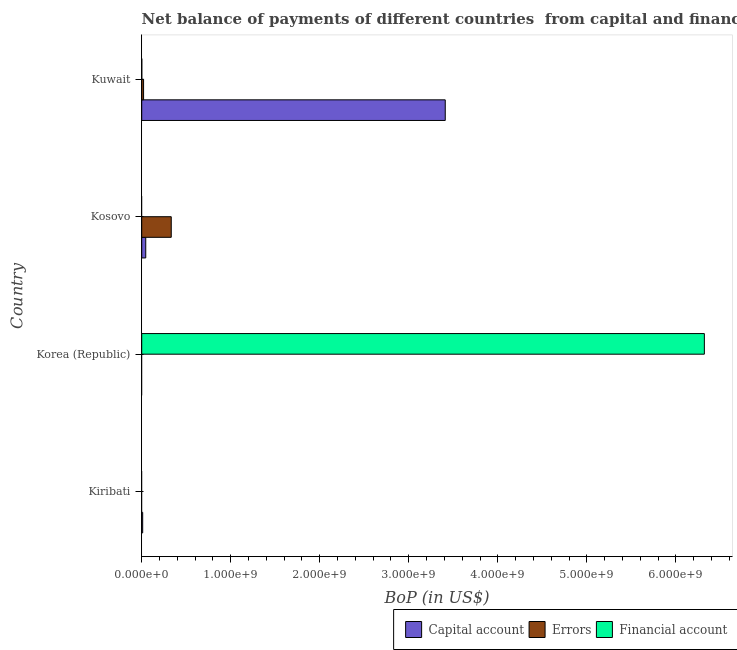Are the number of bars per tick equal to the number of legend labels?
Offer a terse response. No. How many bars are there on the 4th tick from the top?
Keep it short and to the point. 1. What is the label of the 2nd group of bars from the top?
Make the answer very short. Kosovo. What is the amount of financial account in Kiribati?
Offer a very short reply. 0. Across all countries, what is the maximum amount of financial account?
Keep it short and to the point. 6.32e+09. In which country was the amount of errors maximum?
Provide a short and direct response. Kosovo. What is the total amount of errors in the graph?
Provide a short and direct response. 3.53e+08. What is the difference between the amount of financial account in Korea (Republic) and that in Kuwait?
Your answer should be compact. 6.32e+09. What is the difference between the amount of net capital account in Kosovo and the amount of financial account in Korea (Republic)?
Offer a very short reply. -6.28e+09. What is the average amount of errors per country?
Make the answer very short. 8.82e+07. What is the difference between the amount of financial account and amount of net capital account in Kuwait?
Your answer should be compact. -3.41e+09. What is the ratio of the amount of net capital account in Kosovo to that in Kuwait?
Provide a short and direct response. 0.01. What is the difference between the highest and the second highest amount of net capital account?
Your answer should be very brief. 3.36e+09. What is the difference between the highest and the lowest amount of net capital account?
Your answer should be compact. 3.41e+09. In how many countries, is the amount of financial account greater than the average amount of financial account taken over all countries?
Offer a terse response. 1. Is it the case that in every country, the sum of the amount of net capital account and amount of errors is greater than the amount of financial account?
Your response must be concise. No. How many bars are there?
Your answer should be very brief. 7. Are the values on the major ticks of X-axis written in scientific E-notation?
Ensure brevity in your answer.  Yes. Does the graph contain grids?
Make the answer very short. No. Where does the legend appear in the graph?
Provide a short and direct response. Bottom right. What is the title of the graph?
Your answer should be very brief. Net balance of payments of different countries  from capital and financial account. What is the label or title of the X-axis?
Provide a short and direct response. BoP (in US$). What is the label or title of the Y-axis?
Offer a terse response. Country. What is the BoP (in US$) in Capital account in Kiribati?
Ensure brevity in your answer.  1.08e+07. What is the BoP (in US$) in Financial account in Korea (Republic)?
Your answer should be compact. 6.32e+09. What is the BoP (in US$) in Capital account in Kosovo?
Provide a short and direct response. 4.52e+07. What is the BoP (in US$) in Errors in Kosovo?
Offer a very short reply. 3.32e+08. What is the BoP (in US$) in Financial account in Kosovo?
Make the answer very short. 0. What is the BoP (in US$) of Capital account in Kuwait?
Your answer should be compact. 3.41e+09. What is the BoP (in US$) of Errors in Kuwait?
Your response must be concise. 2.09e+07. What is the BoP (in US$) of Financial account in Kuwait?
Ensure brevity in your answer.  8.14e+05. Across all countries, what is the maximum BoP (in US$) in Capital account?
Provide a succinct answer. 3.41e+09. Across all countries, what is the maximum BoP (in US$) of Errors?
Keep it short and to the point. 3.32e+08. Across all countries, what is the maximum BoP (in US$) in Financial account?
Your response must be concise. 6.32e+09. Across all countries, what is the minimum BoP (in US$) in Capital account?
Your response must be concise. 0. Across all countries, what is the minimum BoP (in US$) in Errors?
Give a very brief answer. 0. Across all countries, what is the minimum BoP (in US$) in Financial account?
Provide a succinct answer. 0. What is the total BoP (in US$) in Capital account in the graph?
Keep it short and to the point. 3.47e+09. What is the total BoP (in US$) of Errors in the graph?
Provide a succinct answer. 3.53e+08. What is the total BoP (in US$) of Financial account in the graph?
Your answer should be compact. 6.32e+09. What is the difference between the BoP (in US$) in Capital account in Kiribati and that in Kosovo?
Offer a terse response. -3.44e+07. What is the difference between the BoP (in US$) in Capital account in Kiribati and that in Kuwait?
Ensure brevity in your answer.  -3.40e+09. What is the difference between the BoP (in US$) of Financial account in Korea (Republic) and that in Kuwait?
Your answer should be very brief. 6.32e+09. What is the difference between the BoP (in US$) in Capital account in Kosovo and that in Kuwait?
Keep it short and to the point. -3.36e+09. What is the difference between the BoP (in US$) of Errors in Kosovo and that in Kuwait?
Provide a succinct answer. 3.11e+08. What is the difference between the BoP (in US$) in Capital account in Kiribati and the BoP (in US$) in Financial account in Korea (Republic)?
Provide a succinct answer. -6.31e+09. What is the difference between the BoP (in US$) in Capital account in Kiribati and the BoP (in US$) in Errors in Kosovo?
Keep it short and to the point. -3.21e+08. What is the difference between the BoP (in US$) in Capital account in Kiribati and the BoP (in US$) in Errors in Kuwait?
Offer a terse response. -1.01e+07. What is the difference between the BoP (in US$) in Capital account in Kiribati and the BoP (in US$) in Financial account in Kuwait?
Provide a succinct answer. 9.98e+06. What is the difference between the BoP (in US$) in Capital account in Kosovo and the BoP (in US$) in Errors in Kuwait?
Your answer should be compact. 2.43e+07. What is the difference between the BoP (in US$) of Capital account in Kosovo and the BoP (in US$) of Financial account in Kuwait?
Make the answer very short. 4.44e+07. What is the difference between the BoP (in US$) of Errors in Kosovo and the BoP (in US$) of Financial account in Kuwait?
Your answer should be very brief. 3.31e+08. What is the average BoP (in US$) in Capital account per country?
Offer a terse response. 8.66e+08. What is the average BoP (in US$) of Errors per country?
Give a very brief answer. 8.82e+07. What is the average BoP (in US$) in Financial account per country?
Provide a succinct answer. 1.58e+09. What is the difference between the BoP (in US$) of Capital account and BoP (in US$) of Errors in Kosovo?
Give a very brief answer. -2.86e+08. What is the difference between the BoP (in US$) of Capital account and BoP (in US$) of Errors in Kuwait?
Ensure brevity in your answer.  3.39e+09. What is the difference between the BoP (in US$) in Capital account and BoP (in US$) in Financial account in Kuwait?
Your response must be concise. 3.41e+09. What is the difference between the BoP (in US$) in Errors and BoP (in US$) in Financial account in Kuwait?
Keep it short and to the point. 2.01e+07. What is the ratio of the BoP (in US$) in Capital account in Kiribati to that in Kosovo?
Your response must be concise. 0.24. What is the ratio of the BoP (in US$) in Capital account in Kiribati to that in Kuwait?
Ensure brevity in your answer.  0. What is the ratio of the BoP (in US$) of Financial account in Korea (Republic) to that in Kuwait?
Offer a very short reply. 7761.17. What is the ratio of the BoP (in US$) in Capital account in Kosovo to that in Kuwait?
Provide a succinct answer. 0.01. What is the ratio of the BoP (in US$) of Errors in Kosovo to that in Kuwait?
Keep it short and to the point. 15.85. What is the difference between the highest and the second highest BoP (in US$) of Capital account?
Your response must be concise. 3.36e+09. What is the difference between the highest and the lowest BoP (in US$) in Capital account?
Offer a very short reply. 3.41e+09. What is the difference between the highest and the lowest BoP (in US$) in Errors?
Make the answer very short. 3.32e+08. What is the difference between the highest and the lowest BoP (in US$) of Financial account?
Offer a very short reply. 6.32e+09. 